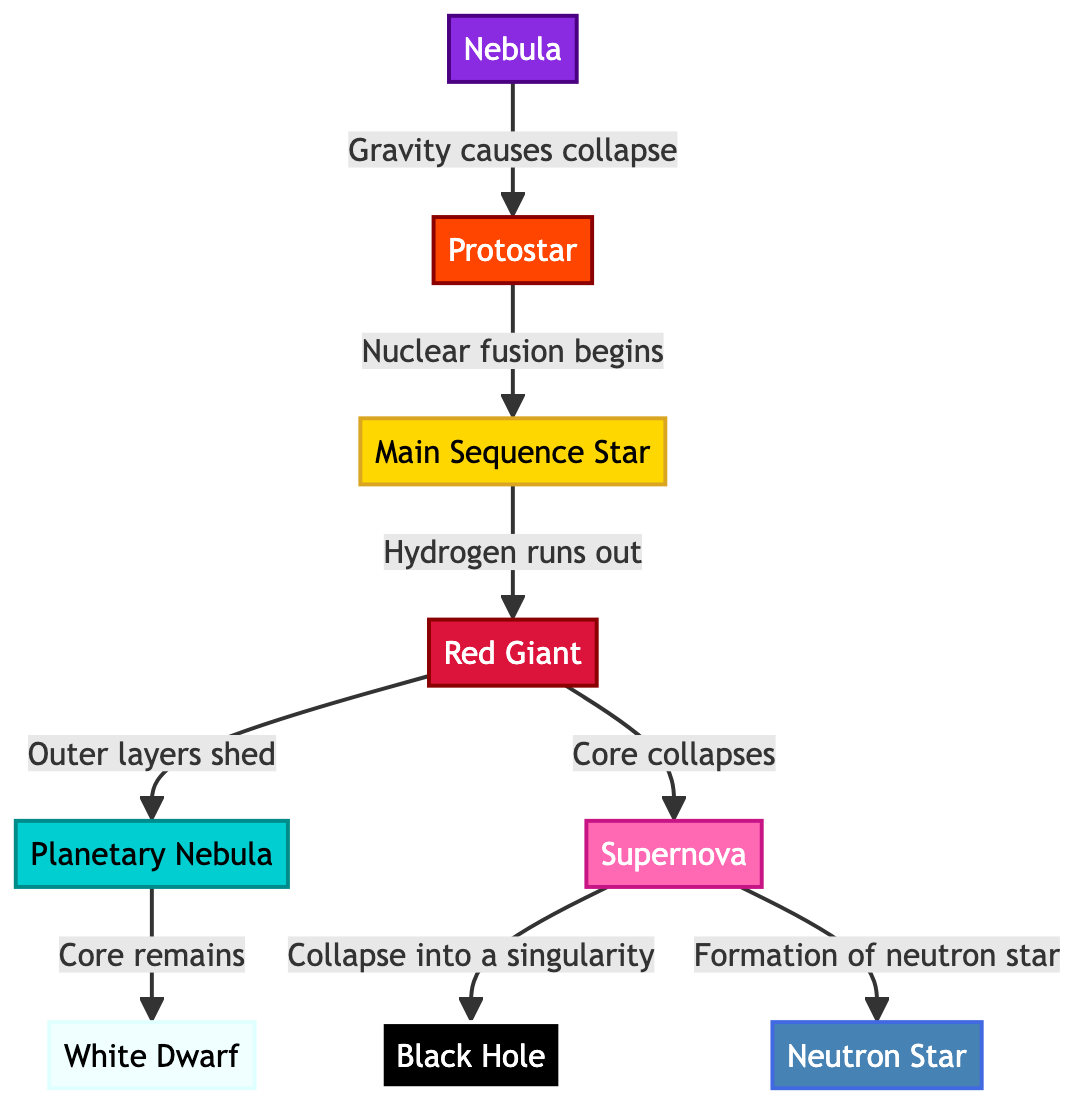What is the first phase of a star's lifecycle? The diagram clearly indicates that the first phase of a star's lifecycle is labeled as "Nebula". This can be seen at the top of the flowchart, with an arrow leading from it to the next phase, which is the Protostar.
Answer: Nebula How many phases are depicted in the diagram? By counting the distinct phases listed in the diagram, we can see several labeled nodes: Nebula, Protostar, Main Sequence Star, Red Giant, Planetary Nebula, White Dwarf, Supernova, Black Hole, and Neutron Star. This totals to nine phases.
Answer: 9 What action occurs when hydrogen runs out? The diagram shows that the action following the depletion of hydrogen in a Main Sequence Star is a transition to the Red Giant phase. An arrow connects the Main Sequence Star to the Red Giant, indicating this progression.
Answer: Red Giant What is formed after a supernova? The diagram reveals that a supernova can lead to two different outcomes: the formation of either a Black Hole or a Neutron Star. The connections from the Supernova phase branch out to these two endpoints.
Answer: Black Hole and Neutron Star What does a Protostar evolve into? The flowchart indicates that a Protostar evolves into a Main Sequence Star. There is a direct arrow linking these two phases, indicating this progression.
Answer: Main Sequence Star What happens to the outer layers of a star during the Red Giant phase? According to the diagram, during the Red Giant phase, the star’s outer layers shed. This is directly specified in the flow from Red Giant to Planetary Nebula.
Answer: Shed What can occur to the core of a Red Giant? The diagram presents two potential outcomes for the core of a Red Giant. It can either remain and evolve into a White Dwarf or collapse, resulting in a Supernova. The connections show these different paths based on the core's fate.
Answer: Collapses or Remains What is the final state of a dying star, depending on its mass? The diagram indicates that a dying star can end in two distinct states: a Black Hole or a Neutron Star after the Supernova explosion. This highlights how the star's mass influences its ending phase.
Answer: Black Hole or Neutron Star 